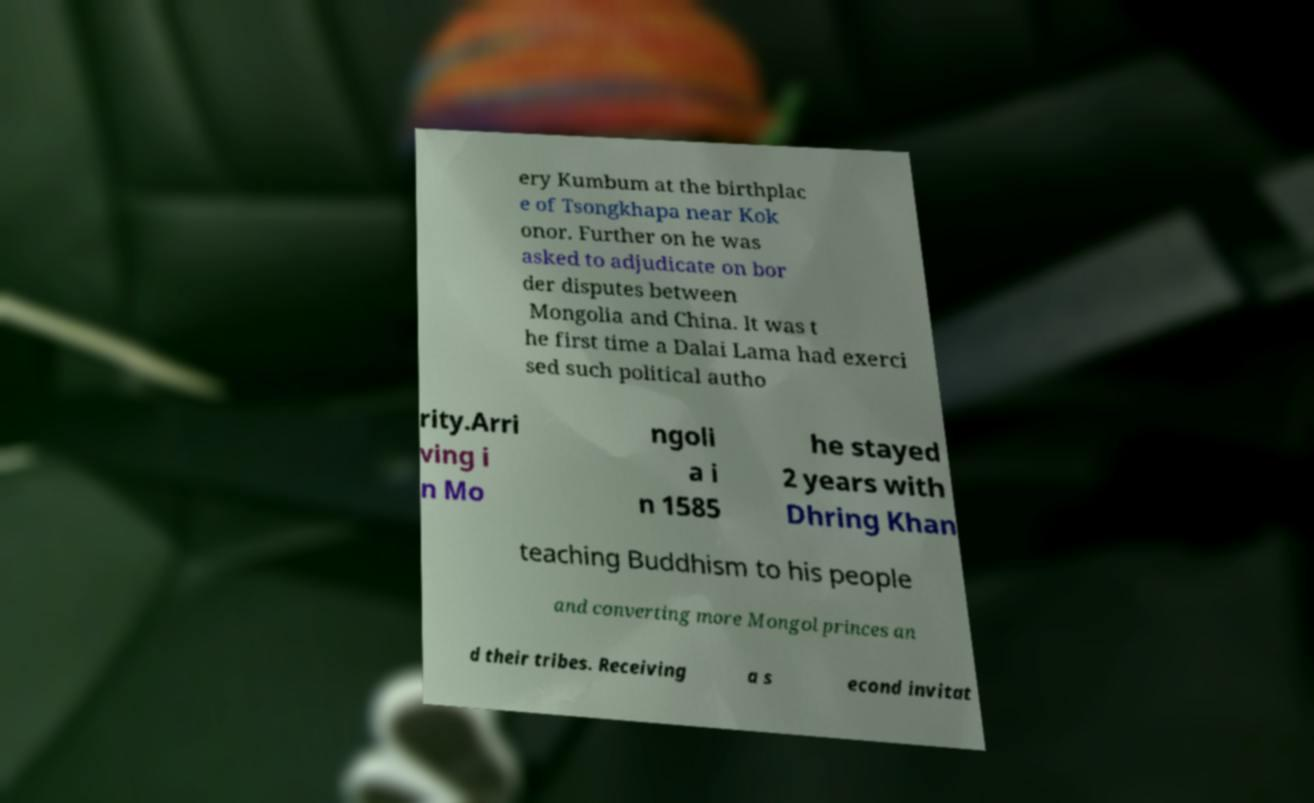What messages or text are displayed in this image? I need them in a readable, typed format. ery Kumbum at the birthplac e of Tsongkhapa near Kok onor. Further on he was asked to adjudicate on bor der disputes between Mongolia and China. It was t he first time a Dalai Lama had exerci sed such political autho rity.Arri ving i n Mo ngoli a i n 1585 he stayed 2 years with Dhring Khan teaching Buddhism to his people and converting more Mongol princes an d their tribes. Receiving a s econd invitat 